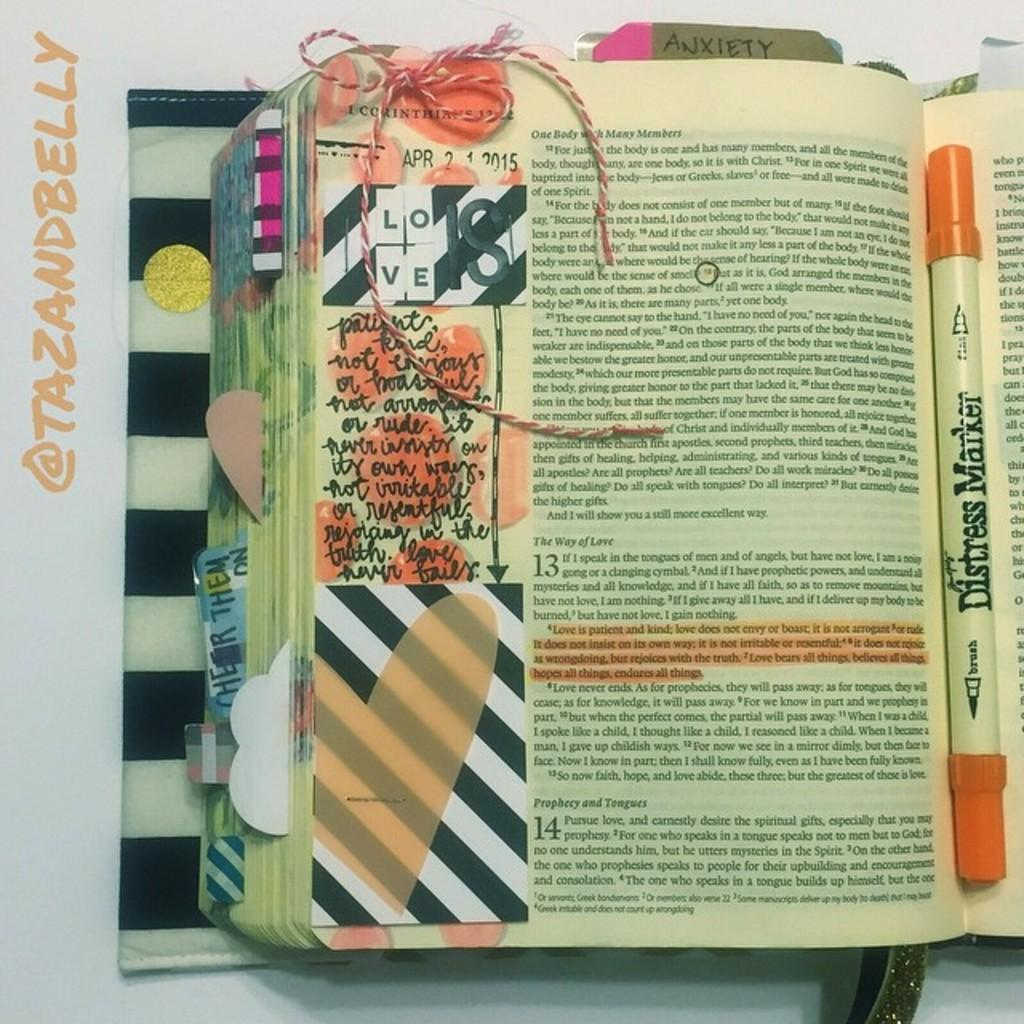<image>
Describe the image concisely. An open book with a section labeled "ANXIETY" 